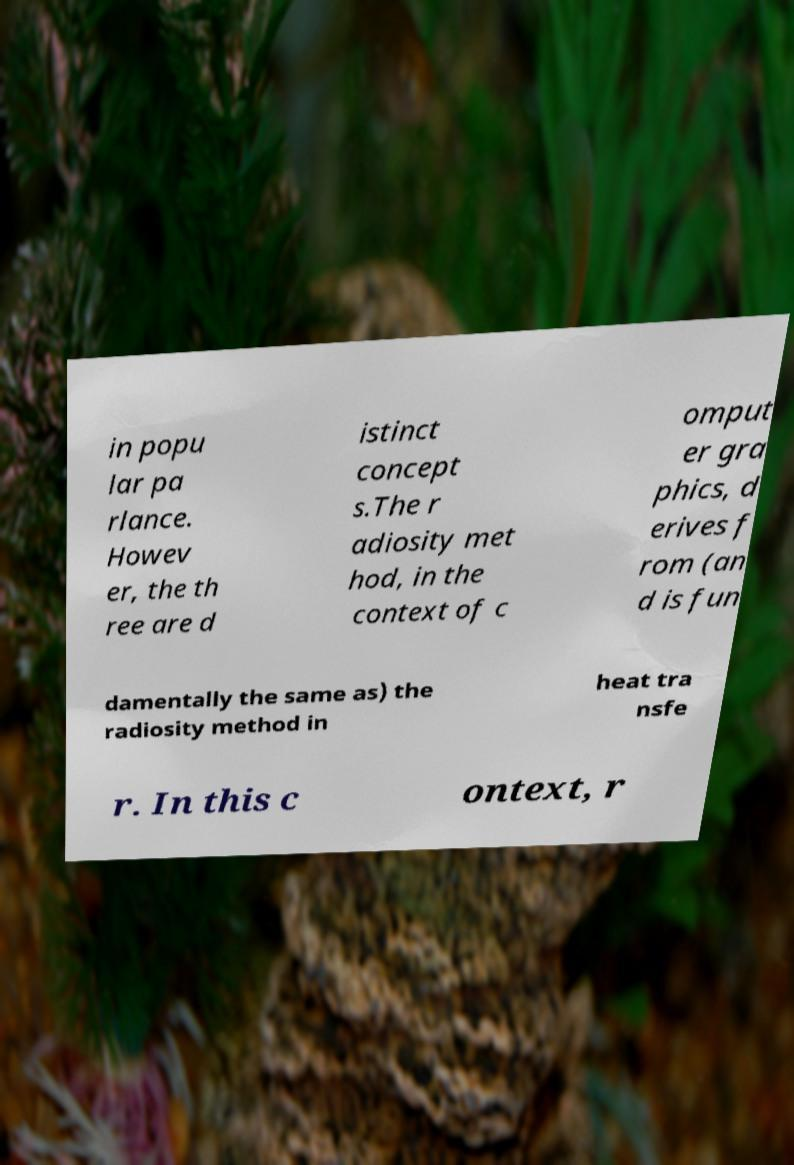Could you assist in decoding the text presented in this image and type it out clearly? in popu lar pa rlance. Howev er, the th ree are d istinct concept s.The r adiosity met hod, in the context of c omput er gra phics, d erives f rom (an d is fun damentally the same as) the radiosity method in heat tra nsfe r. In this c ontext, r 